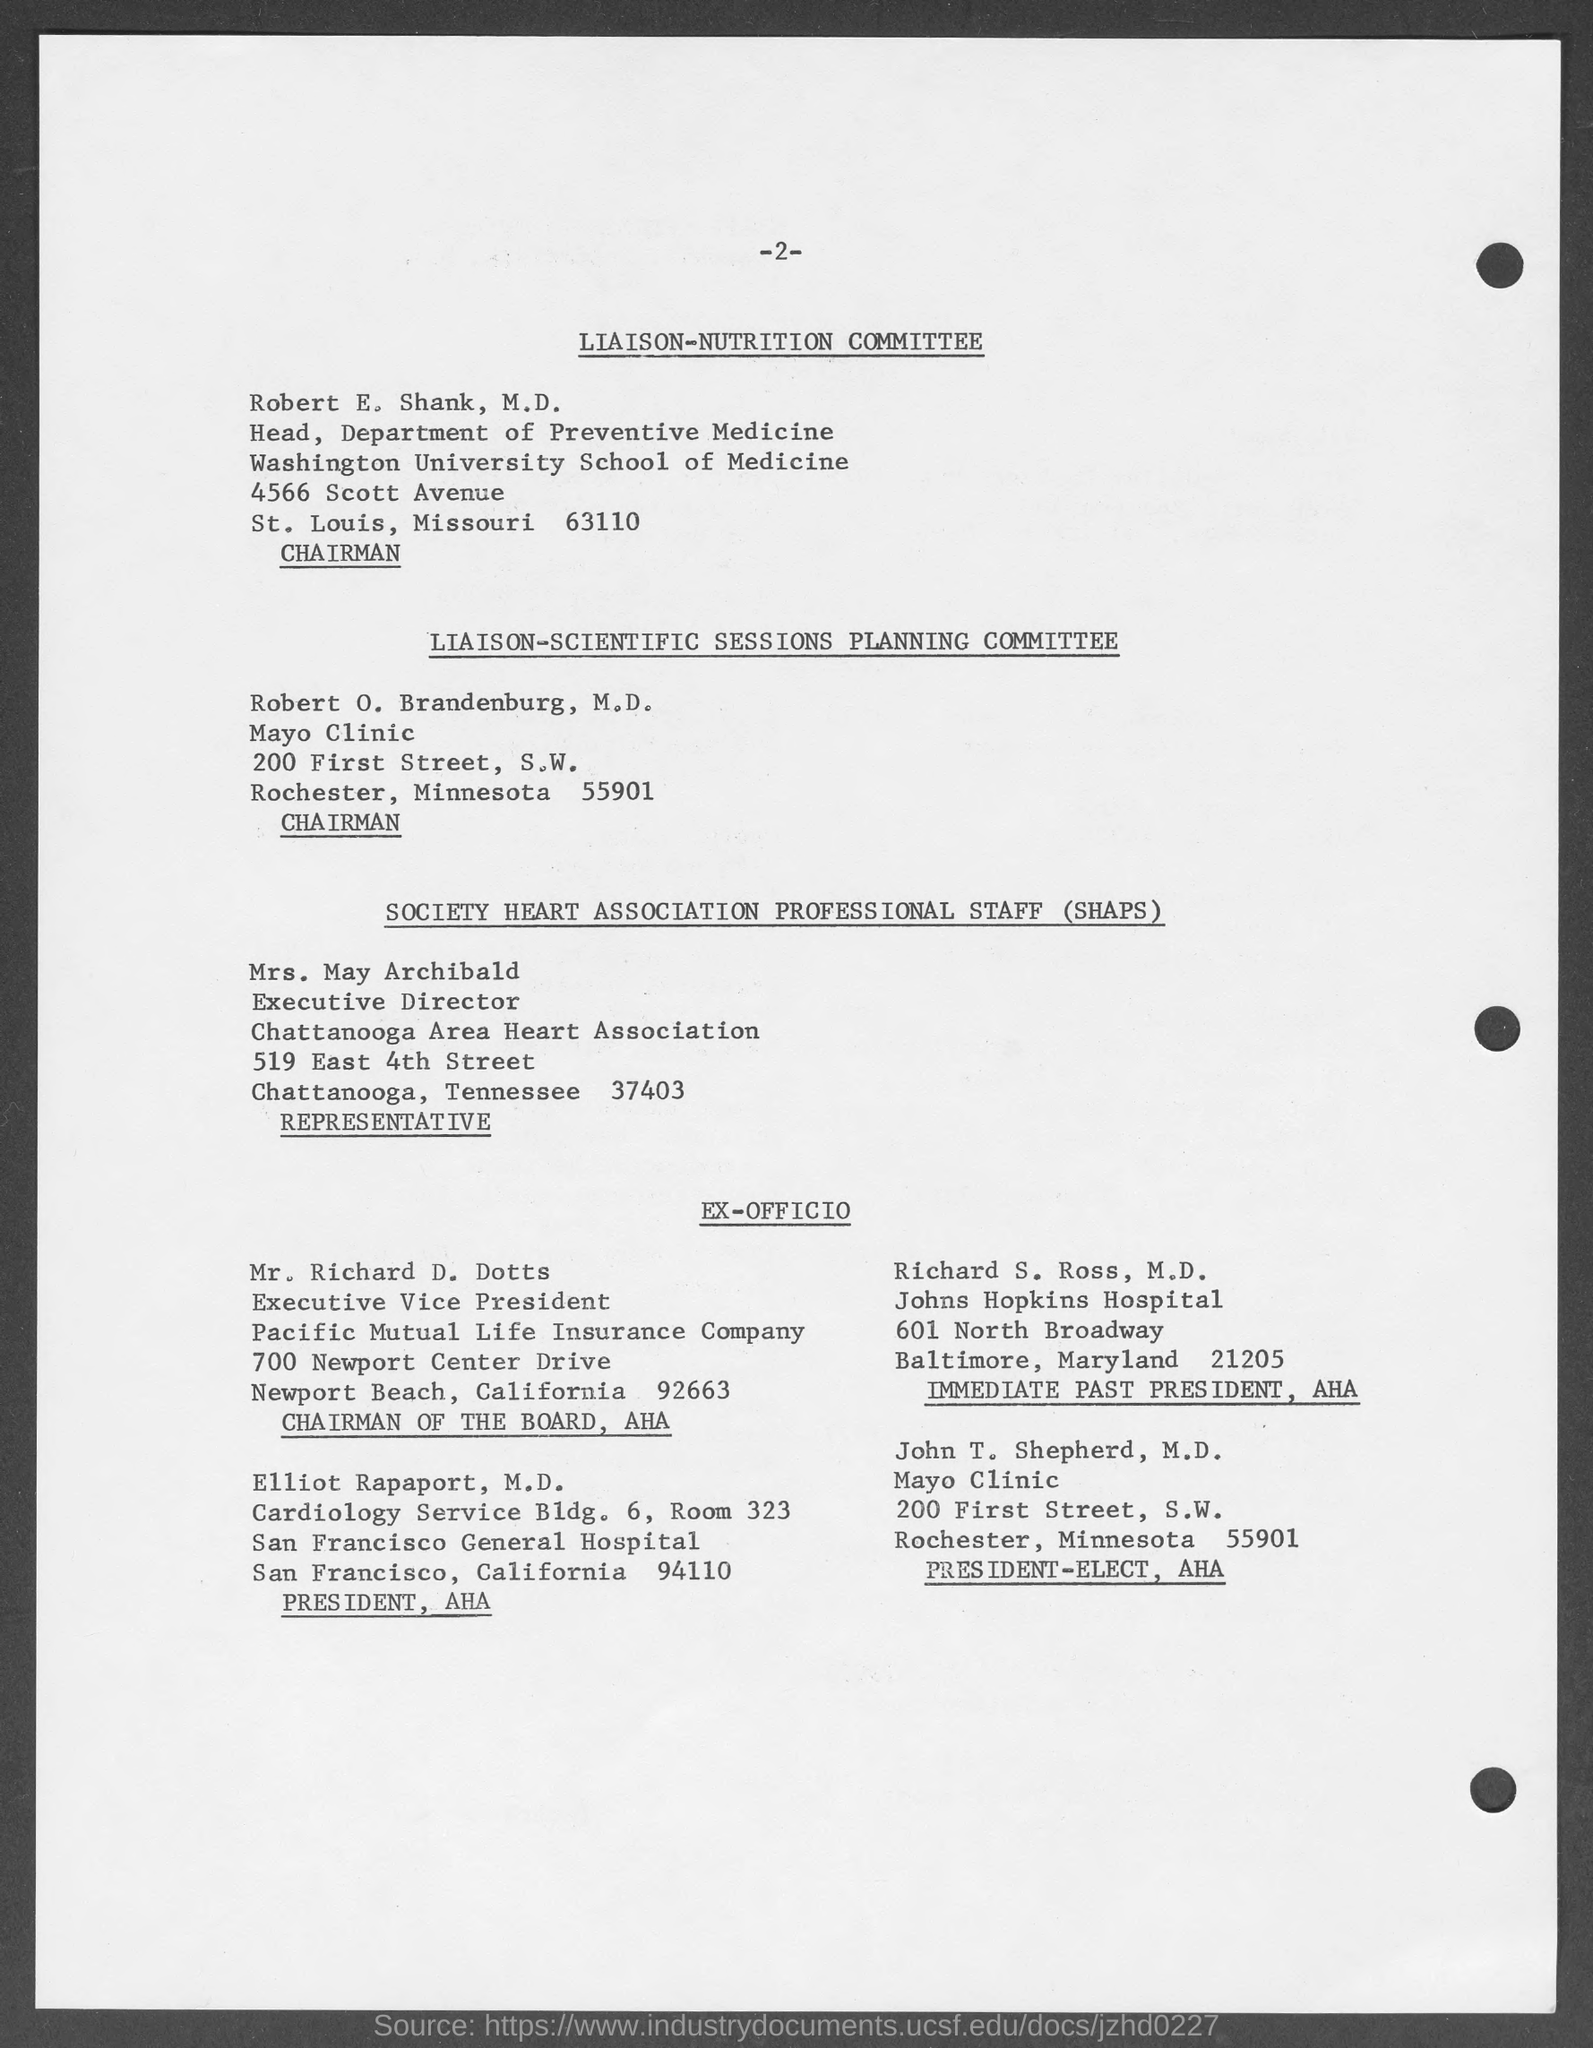Draw attention to some important aspects in this diagram. The page number mentioned in this document is -2-. The chairman of LIAISON-NUTRITION COMMITTEE is Robert E. Shank. SHAPS stands for Society Heart Association Professional Staff. The Chairman of the Board at AHA is Mr. Richard D. Dotts. Robert E. Shank, M.D. is the head of the department of preventive medicine. 